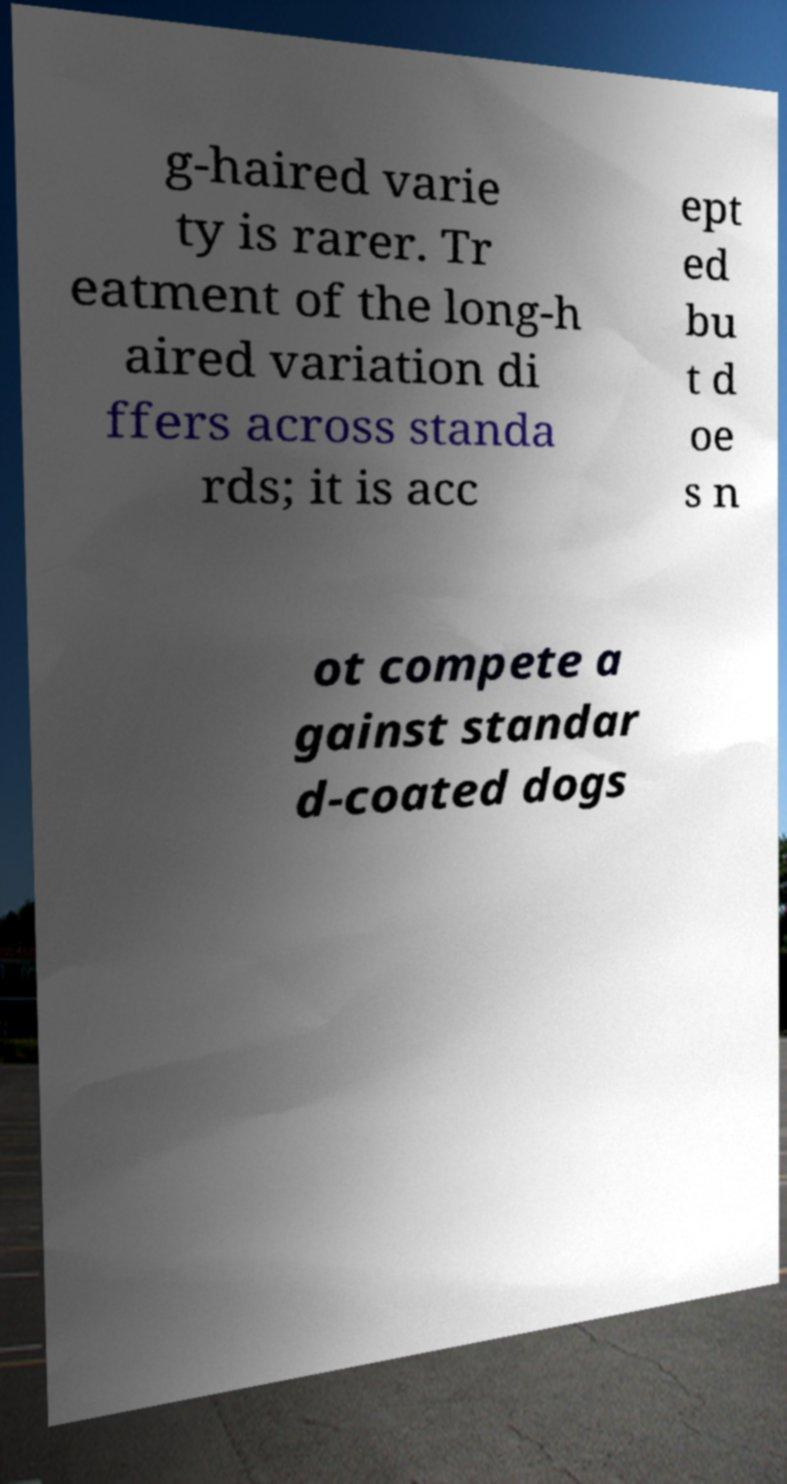Could you extract and type out the text from this image? g-haired varie ty is rarer. Tr eatment of the long-h aired variation di ffers across standa rds; it is acc ept ed bu t d oe s n ot compete a gainst standar d-coated dogs 